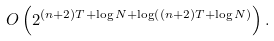<formula> <loc_0><loc_0><loc_500><loc_500>O \left ( 2 ^ { ( n + 2 ) T + \log N + \log \left ( ( n + 2 ) T + \log N \right ) } \right ) .</formula> 